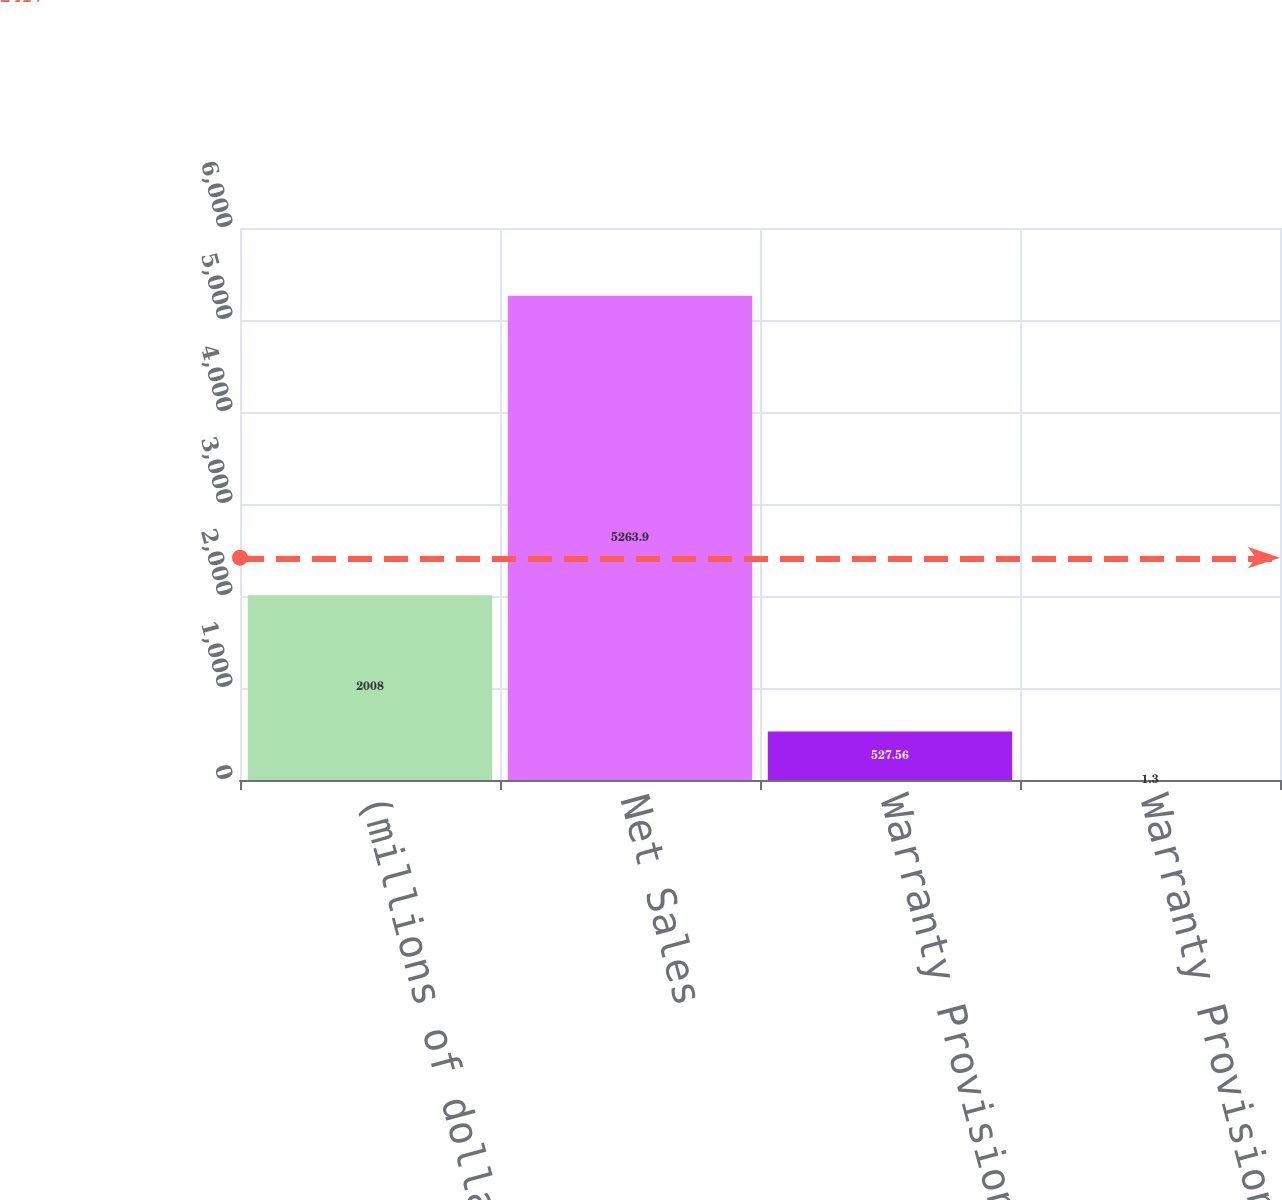Convert chart to OTSL. <chart><loc_0><loc_0><loc_500><loc_500><bar_chart><fcel>(millions of dollars)<fcel>Net Sales<fcel>Warranty Provision<fcel>Warranty Provision as a<nl><fcel>2008<fcel>5263.9<fcel>527.56<fcel>1.3<nl></chart> 